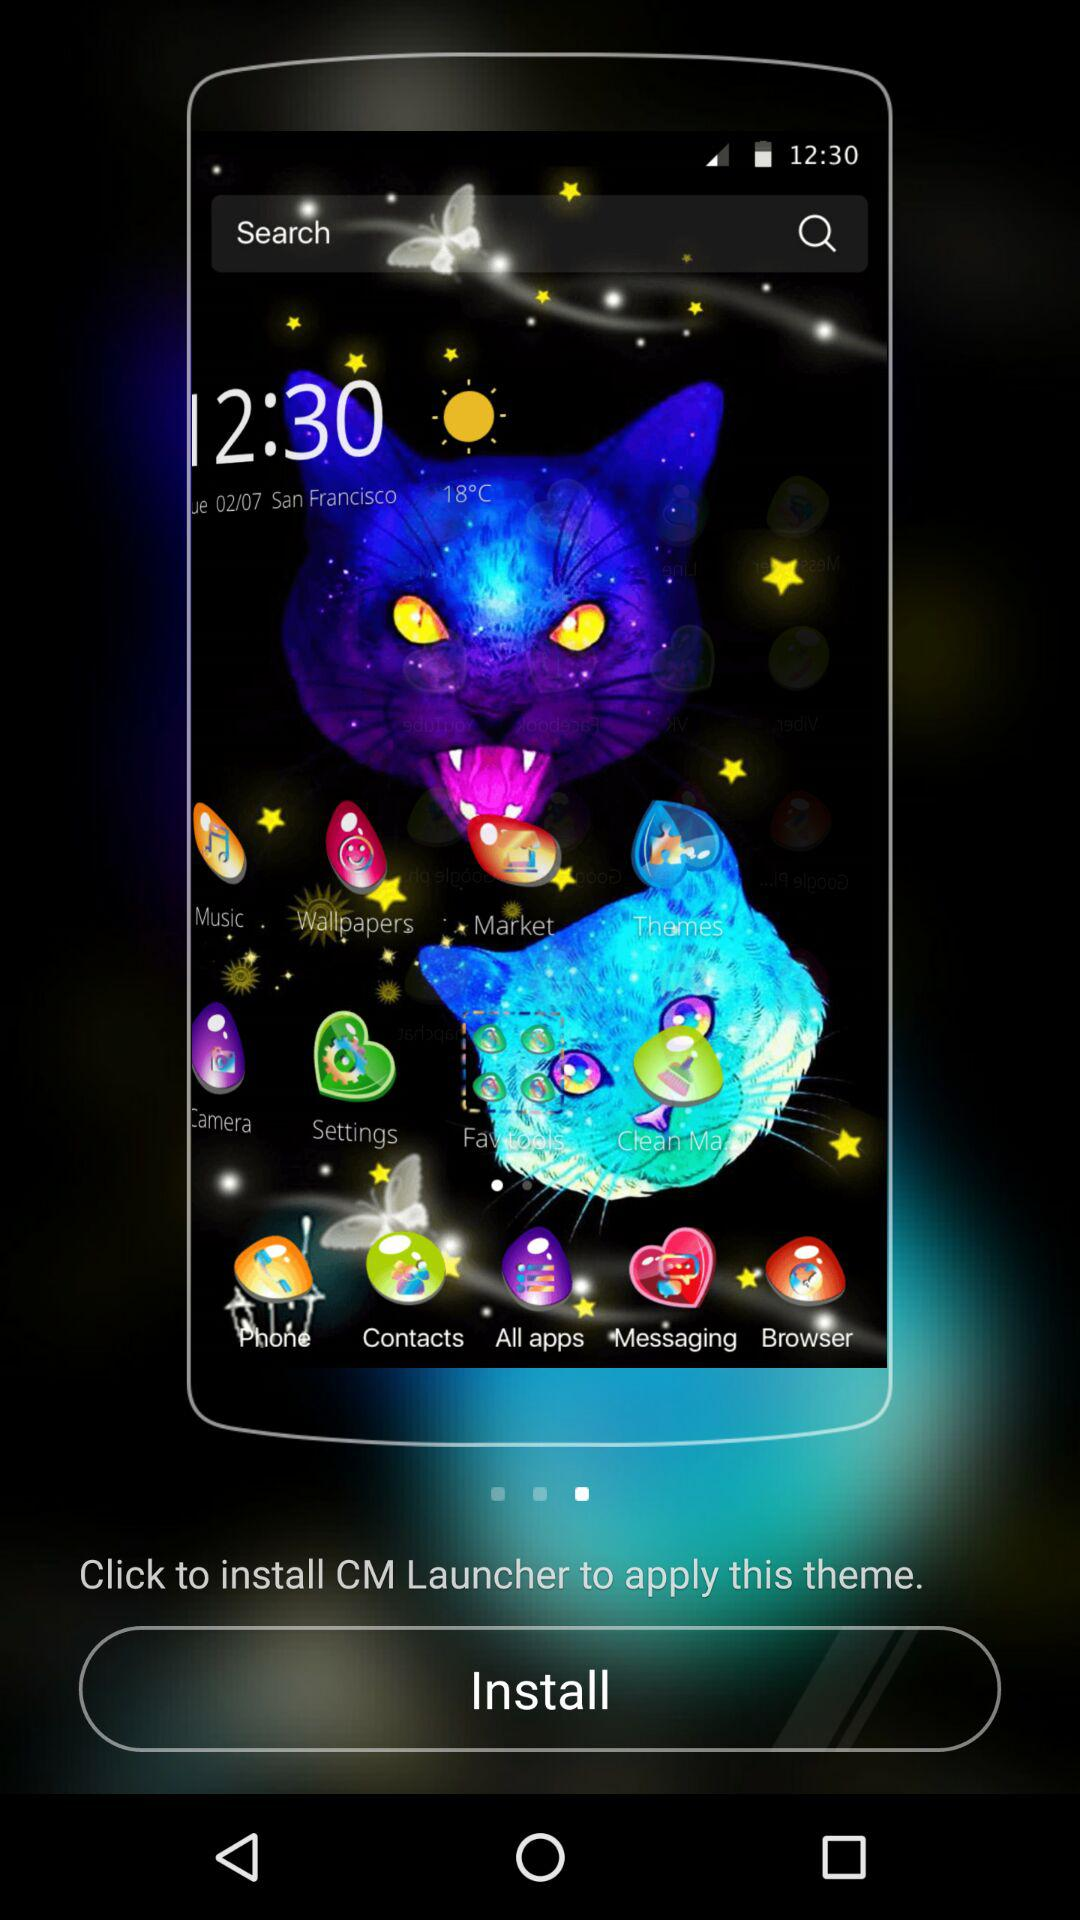What is the time? The time is 12:30. 